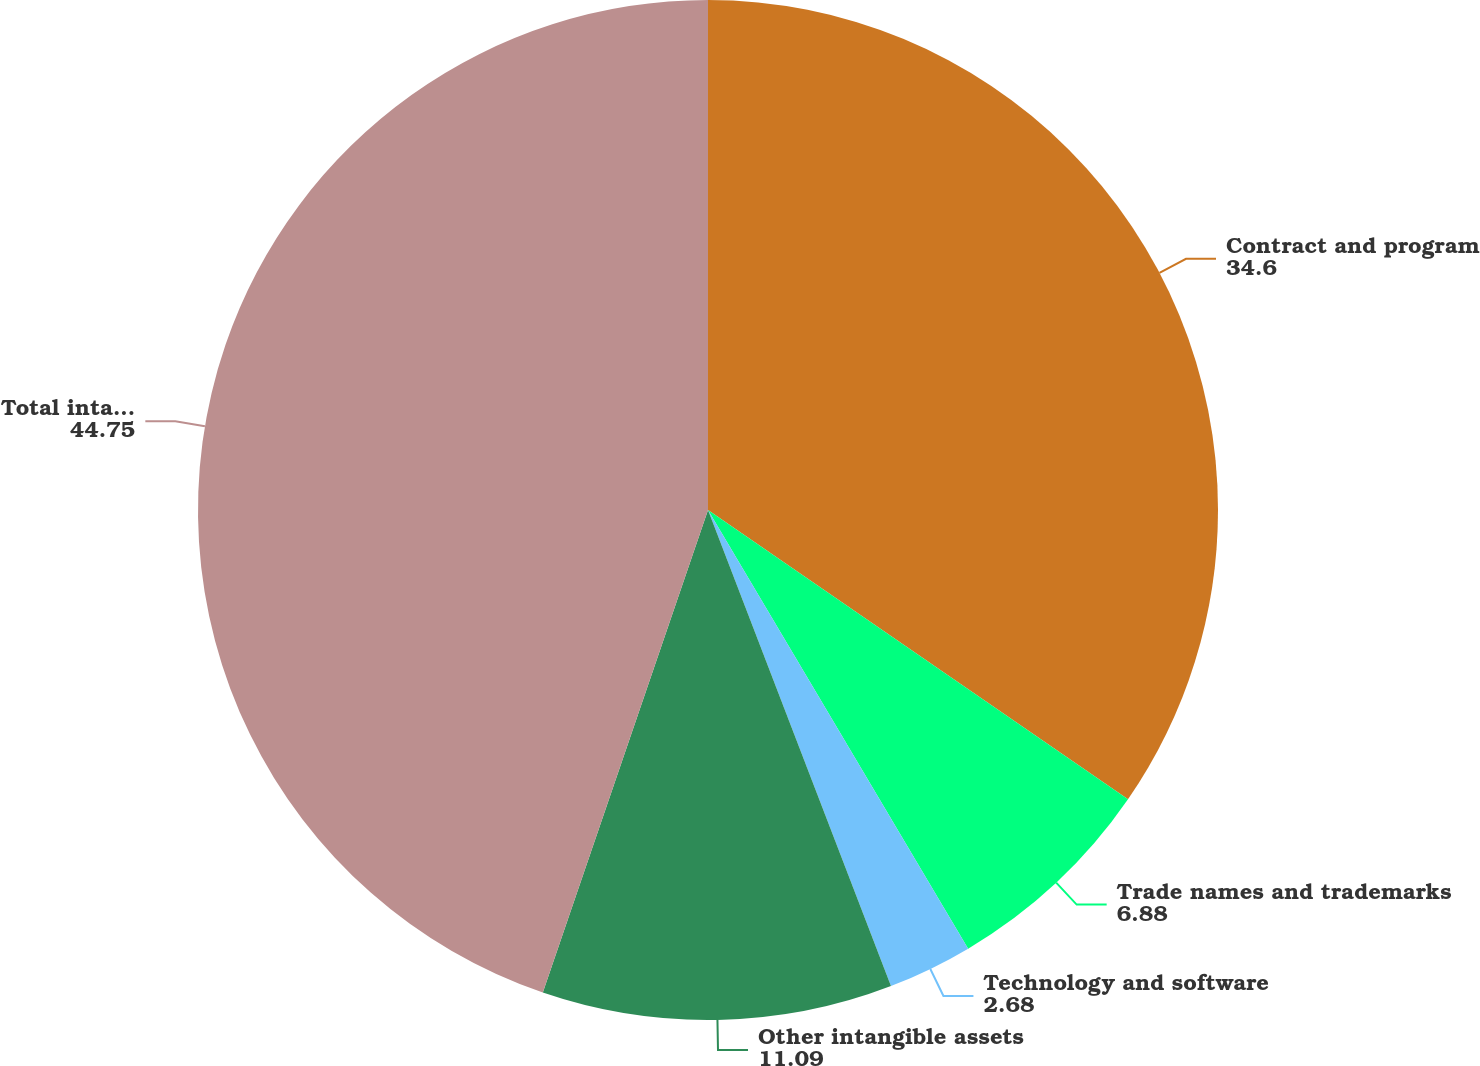<chart> <loc_0><loc_0><loc_500><loc_500><pie_chart><fcel>Contract and program<fcel>Trade names and trademarks<fcel>Technology and software<fcel>Other intangible assets<fcel>Total intangible assets<nl><fcel>34.6%<fcel>6.88%<fcel>2.68%<fcel>11.09%<fcel>44.75%<nl></chart> 